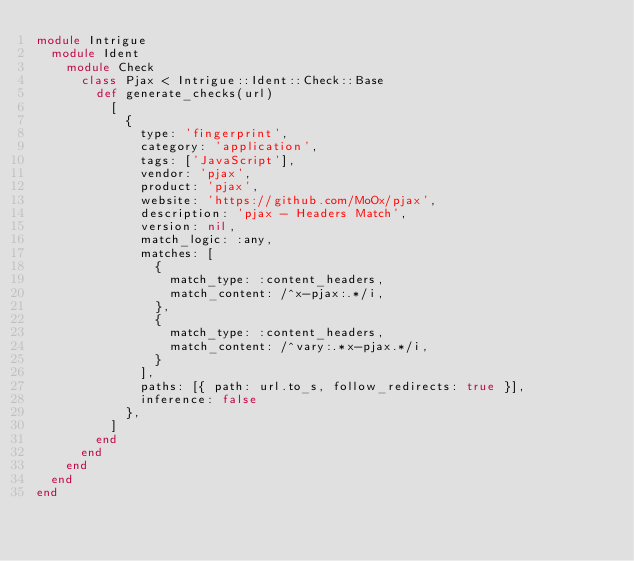Convert code to text. <code><loc_0><loc_0><loc_500><loc_500><_Ruby_>module Intrigue
  module Ident
    module Check
      class Pjax < Intrigue::Ident::Check::Base
        def generate_checks(url)
          [
            {
              type: 'fingerprint',
              category: 'application',
              tags: ['JavaScript'],
              vendor: 'pjax',
              product: 'pjax',
              website: 'https://github.com/MoOx/pjax',
              description: 'pjax - Headers Match',
              version: nil,
              match_logic: :any,
              matches: [
                {
                  match_type: :content_headers,
                  match_content: /^x-pjax:.*/i,
                },
                {
                  match_type: :content_headers,
                  match_content: /^vary:.*x-pjax.*/i,
                }
              ],
              paths: [{ path: url.to_s, follow_redirects: true }],
              inference: false
            },
          ]
        end
      end
    end
  end
end
</code> 